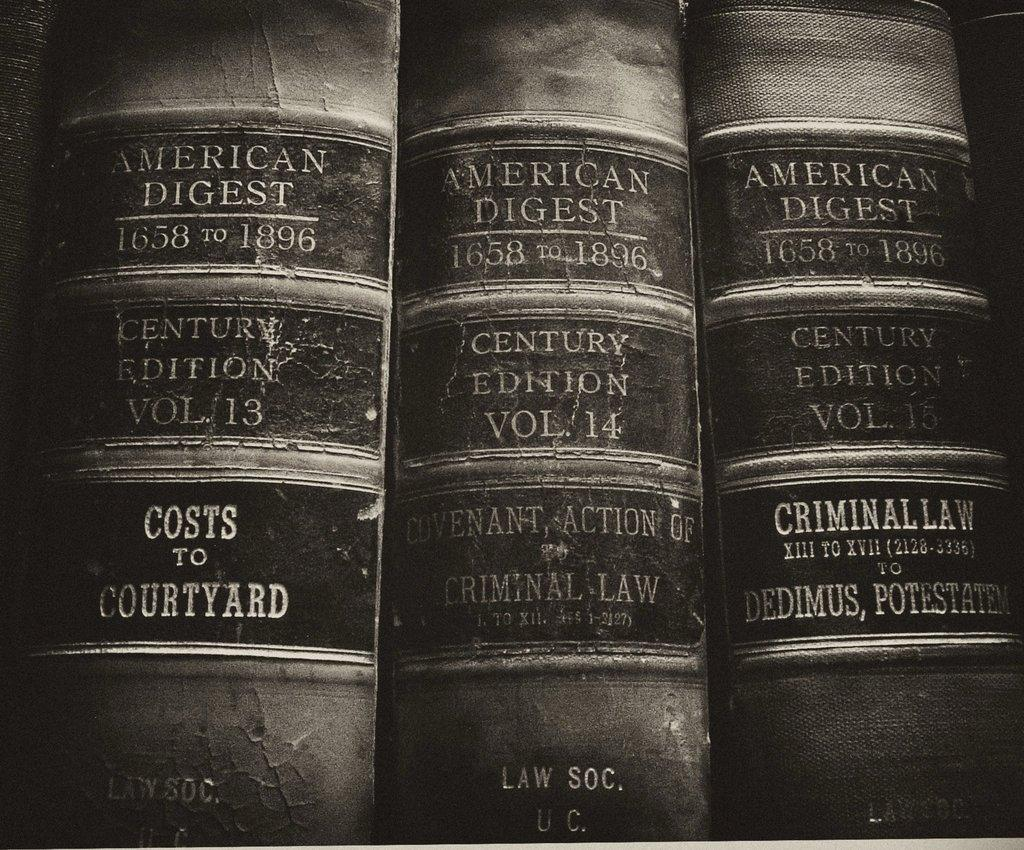Provide a one-sentence caption for the provided image. three american digest books law books vol 13 14 and 15. 